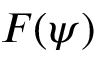Convert formula to latex. <formula><loc_0><loc_0><loc_500><loc_500>F ( \psi )</formula> 